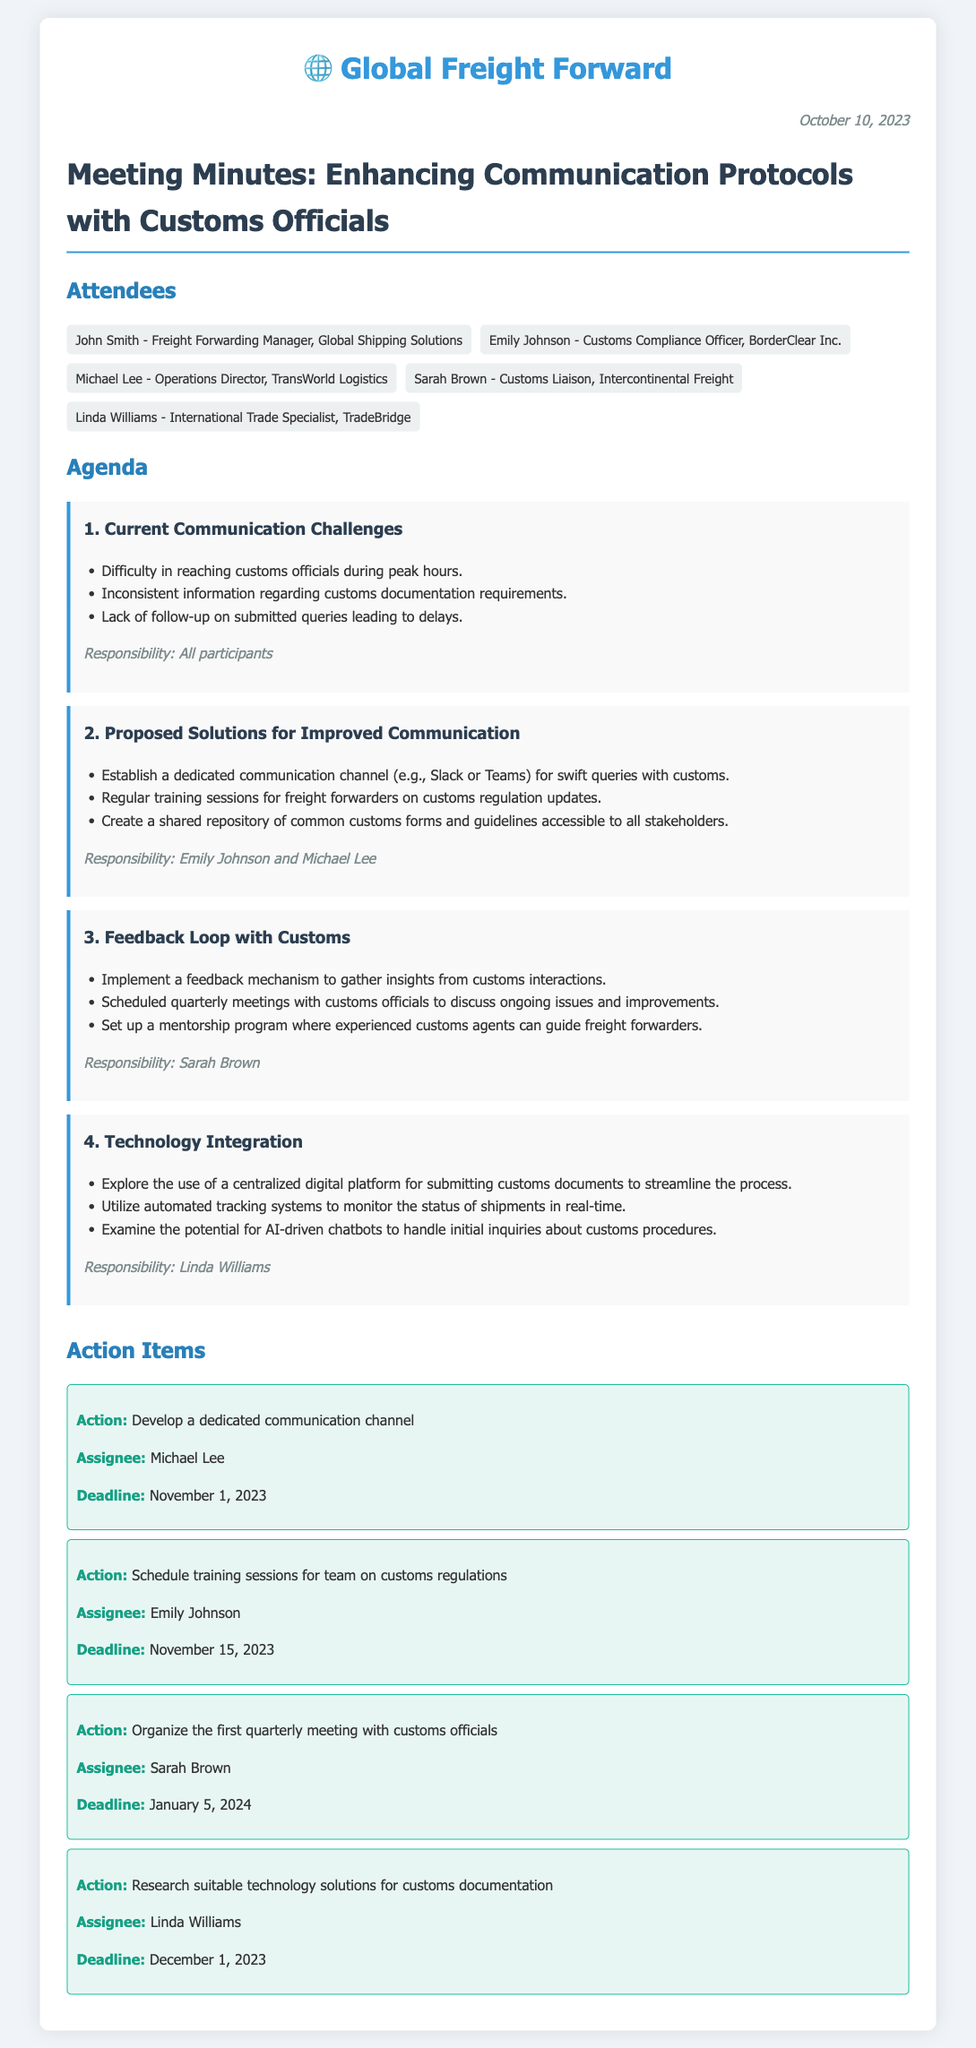What is the date of the meeting? The date is mentioned clearly in the document, stating the meeting took place on October 10, 2023.
Answer: October 10, 2023 Who is responsible for developing a dedicated communication channel? The action item specifies that Michael Lee is the assignee for this task.
Answer: Michael Lee What is one of the current communication challenges mentioned? The document lists difficulties faced under current challenges, such as reaching customs officials during peak hours.
Answer: Difficulty in reaching customs officials during peak hours When is the deadline for scheduling training sessions on customs regulations? The document states that Emily Johnson is tasked with this action item, and the deadline is clearly indicated.
Answer: November 15, 2023 What technology solution is suggested for customs documentation? One of the proposed solutions mentions exploring the use of a centralized digital platform for submissions.
Answer: Centralized digital platform What is one proposed solution to improve communication with customs? Among the proposed solutions, establishing a dedicated communication channel is highlighted as a way to improve communication.
Answer: Dedicated communication channel What is the purpose of the feedback loop with customs? The section on feedback loop explains it is for gathering insights from customs interactions to improve communication processes.
Answer: Gather insights from customs interactions How frequently are the meetings with customs officials scheduled? The document mentions that the meetings will be scheduled quarterly to discuss ongoing issues and improvements.
Answer: Quarterly meetings 